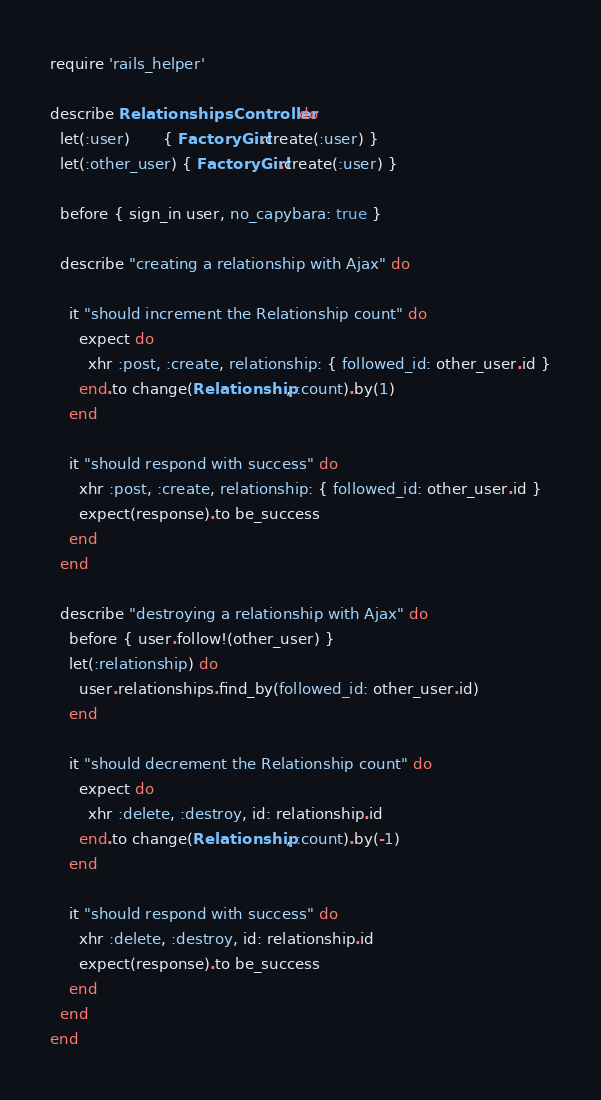<code> <loc_0><loc_0><loc_500><loc_500><_Ruby_>require 'rails_helper'

describe RelationshipsController do
  let(:user)       { FactoryGirl.create(:user) }
  let(:other_user) { FactoryGirl.create(:user) }

  before { sign_in user, no_capybara: true }

  describe "creating a relationship with Ajax" do

    it "should increment the Relationship count" do
      expect do
        xhr :post, :create, relationship: { followed_id: other_user.id }
      end.to change(Relationship, :count).by(1)
    end

    it "should respond with success" do
      xhr :post, :create, relationship: { followed_id: other_user.id }
      expect(response).to be_success
    end
  end

  describe "destroying a relationship with Ajax" do
    before { user.follow!(other_user) }
    let(:relationship) do
      user.relationships.find_by(followed_id: other_user.id)
    end

    it "should decrement the Relationship count" do
      expect do
        xhr :delete, :destroy, id: relationship.id
      end.to change(Relationship, :count).by(-1)
    end

    it "should respond with success" do
      xhr :delete, :destroy, id: relationship.id
      expect(response).to be_success
    end
  end
end
</code> 